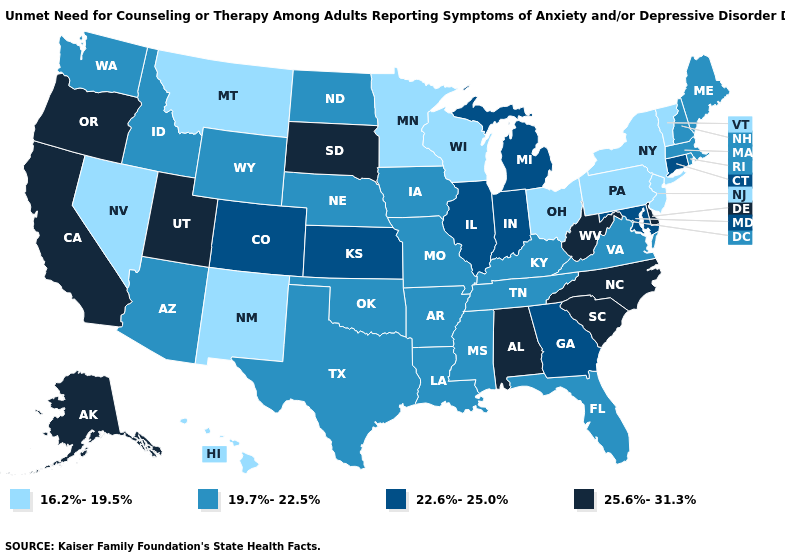What is the highest value in the Northeast ?
Concise answer only. 22.6%-25.0%. Which states have the lowest value in the USA?
Be succinct. Hawaii, Minnesota, Montana, Nevada, New Jersey, New Mexico, New York, Ohio, Pennsylvania, Vermont, Wisconsin. What is the lowest value in the West?
Write a very short answer. 16.2%-19.5%. What is the value of Vermont?
Quick response, please. 16.2%-19.5%. Name the states that have a value in the range 19.7%-22.5%?
Be succinct. Arizona, Arkansas, Florida, Idaho, Iowa, Kentucky, Louisiana, Maine, Massachusetts, Mississippi, Missouri, Nebraska, New Hampshire, North Dakota, Oklahoma, Rhode Island, Tennessee, Texas, Virginia, Washington, Wyoming. Does Florida have the same value as Rhode Island?
Quick response, please. Yes. Which states have the lowest value in the MidWest?
Quick response, please. Minnesota, Ohio, Wisconsin. What is the lowest value in the MidWest?
Give a very brief answer. 16.2%-19.5%. Name the states that have a value in the range 16.2%-19.5%?
Quick response, please. Hawaii, Minnesota, Montana, Nevada, New Jersey, New Mexico, New York, Ohio, Pennsylvania, Vermont, Wisconsin. Among the states that border Pennsylvania , does Delaware have the highest value?
Short answer required. Yes. Among the states that border Iowa , does Illinois have the highest value?
Short answer required. No. Name the states that have a value in the range 25.6%-31.3%?
Answer briefly. Alabama, Alaska, California, Delaware, North Carolina, Oregon, South Carolina, South Dakota, Utah, West Virginia. What is the highest value in the Northeast ?
Give a very brief answer. 22.6%-25.0%. Which states hav the highest value in the MidWest?
Keep it brief. South Dakota. Is the legend a continuous bar?
Concise answer only. No. 